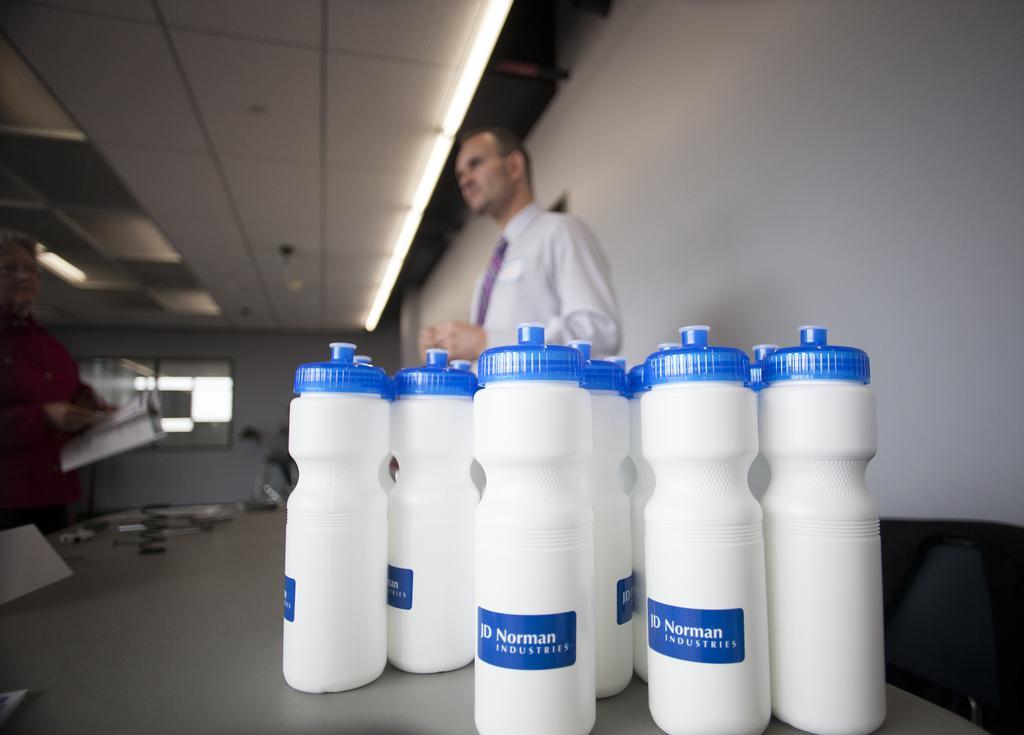Could you give a brief overview of what you see in this image? In this image we have group of bottles placed in the table and at the back ground we have a man standing , a wall , lights attached to the ceiling , an another person standing by holding the book. 